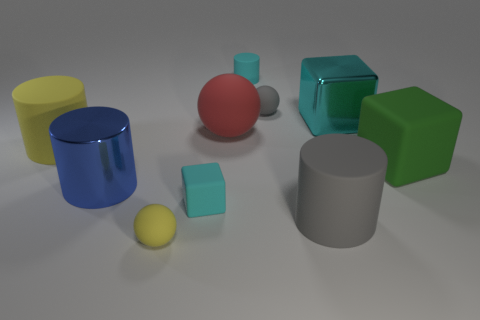How many cyan cubes must be subtracted to get 1 cyan cubes? 1 Subtract all cyan shiny blocks. How many blocks are left? 2 Subtract 1 cubes. How many cubes are left? 2 Subtract all yellow cylinders. How many cylinders are left? 3 Add 6 green things. How many green things exist? 7 Subtract 0 purple balls. How many objects are left? 10 Subtract all cylinders. How many objects are left? 6 Subtract all green balls. Subtract all red cubes. How many balls are left? 3 Subtract all green balls. How many green blocks are left? 1 Subtract all cyan metal balls. Subtract all cyan metallic blocks. How many objects are left? 9 